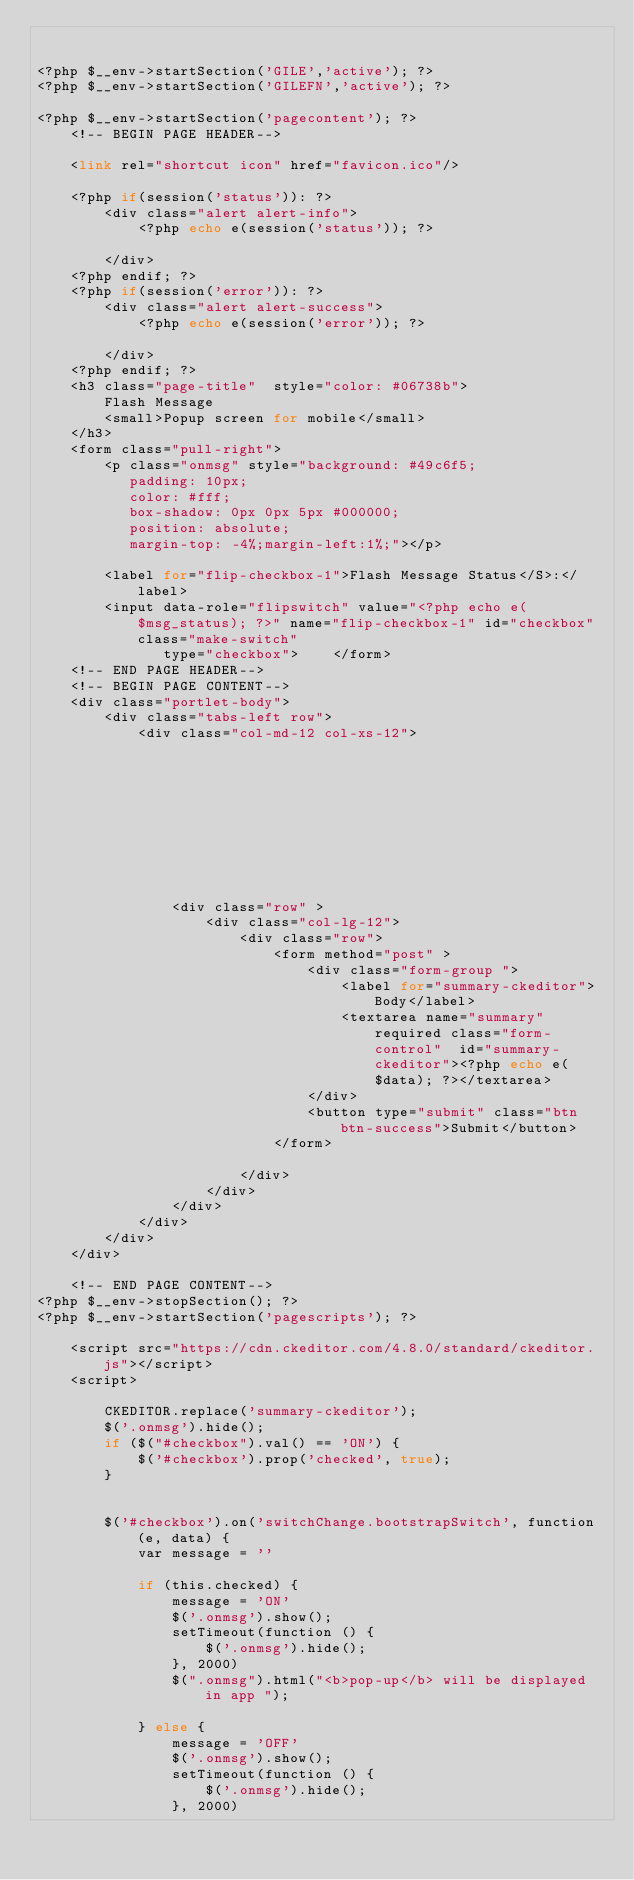Convert code to text. <code><loc_0><loc_0><loc_500><loc_500><_PHP_>

<?php $__env->startSection('GILE','active'); ?>
<?php $__env->startSection('GILEFN','active'); ?>

<?php $__env->startSection('pagecontent'); ?>
    <!-- BEGIN PAGE HEADER-->

    <link rel="shortcut icon" href="favicon.ico"/>

    <?php if(session('status')): ?>
        <div class="alert alert-info">
            <?php echo e(session('status')); ?>

        </div>
    <?php endif; ?>
    <?php if(session('error')): ?>
        <div class="alert alert-success">
            <?php echo e(session('error')); ?>

        </div>
    <?php endif; ?>
    <h3 class="page-title"  style="color: #06738b">
        Flash Message
        <small>Popup screen for mobile</small>
    </h3>
    <form class="pull-right">
        <p class="onmsg" style="background: #49c6f5;
           padding: 10px;
           color: #fff;
           box-shadow: 0px 0px 5px #000000;
           position: absolute;
           margin-top: -4%;margin-left:1%;"></p>

        <label for="flip-checkbox-1">Flash Message Status</S>:</label>
        <input data-role="flipswitch" value="<?php echo e($msg_status); ?>" name="flip-checkbox-1" id="checkbox" class="make-switch"
               type="checkbox">    </form>
    <!-- END PAGE HEADER-->
    <!-- BEGIN PAGE CONTENT-->
    <div class="portlet-body">
        <div class="tabs-left row">
            <div class="col-md-12 col-xs-12">
                
                
                
                
                
                
                
                
                
                
                <div class="row" >
                    <div class="col-lg-12">
                        <div class="row">
                            <form method="post" >
                                <div class="form-group ">
                                    <label for="summary-ckeditor">Body</label>
                                    <textarea name="summary" required class="form-control"  id="summary-ckeditor"><?php echo e($data); ?></textarea>
                                </div>
                                <button type="submit" class="btn btn-success">Submit</button>
                            </form>

                        </div>
                    </div>
                </div>
            </div>
        </div>
    </div>

    <!-- END PAGE CONTENT-->
<?php $__env->stopSection(); ?>
<?php $__env->startSection('pagescripts'); ?>
    
    <script src="https://cdn.ckeditor.com/4.8.0/standard/ckeditor.js"></script>
    <script>

        CKEDITOR.replace('summary-ckeditor');
        $('.onmsg').hide();
        if ($("#checkbox").val() == 'ON') {
            $('#checkbox').prop('checked', true);
        }


        $('#checkbox').on('switchChange.bootstrapSwitch', function (e, data) {
            var message = ''

            if (this.checked) {
                message = 'ON'
                $('.onmsg').show();
                setTimeout(function () {
                    $('.onmsg').hide();
                }, 2000)
                $(".onmsg").html("<b>pop-up</b> will be displayed in app ");

            } else {
                message = 'OFF'
                $('.onmsg').show();
                setTimeout(function () {
                    $('.onmsg').hide();
                }, 2000)
</code> 